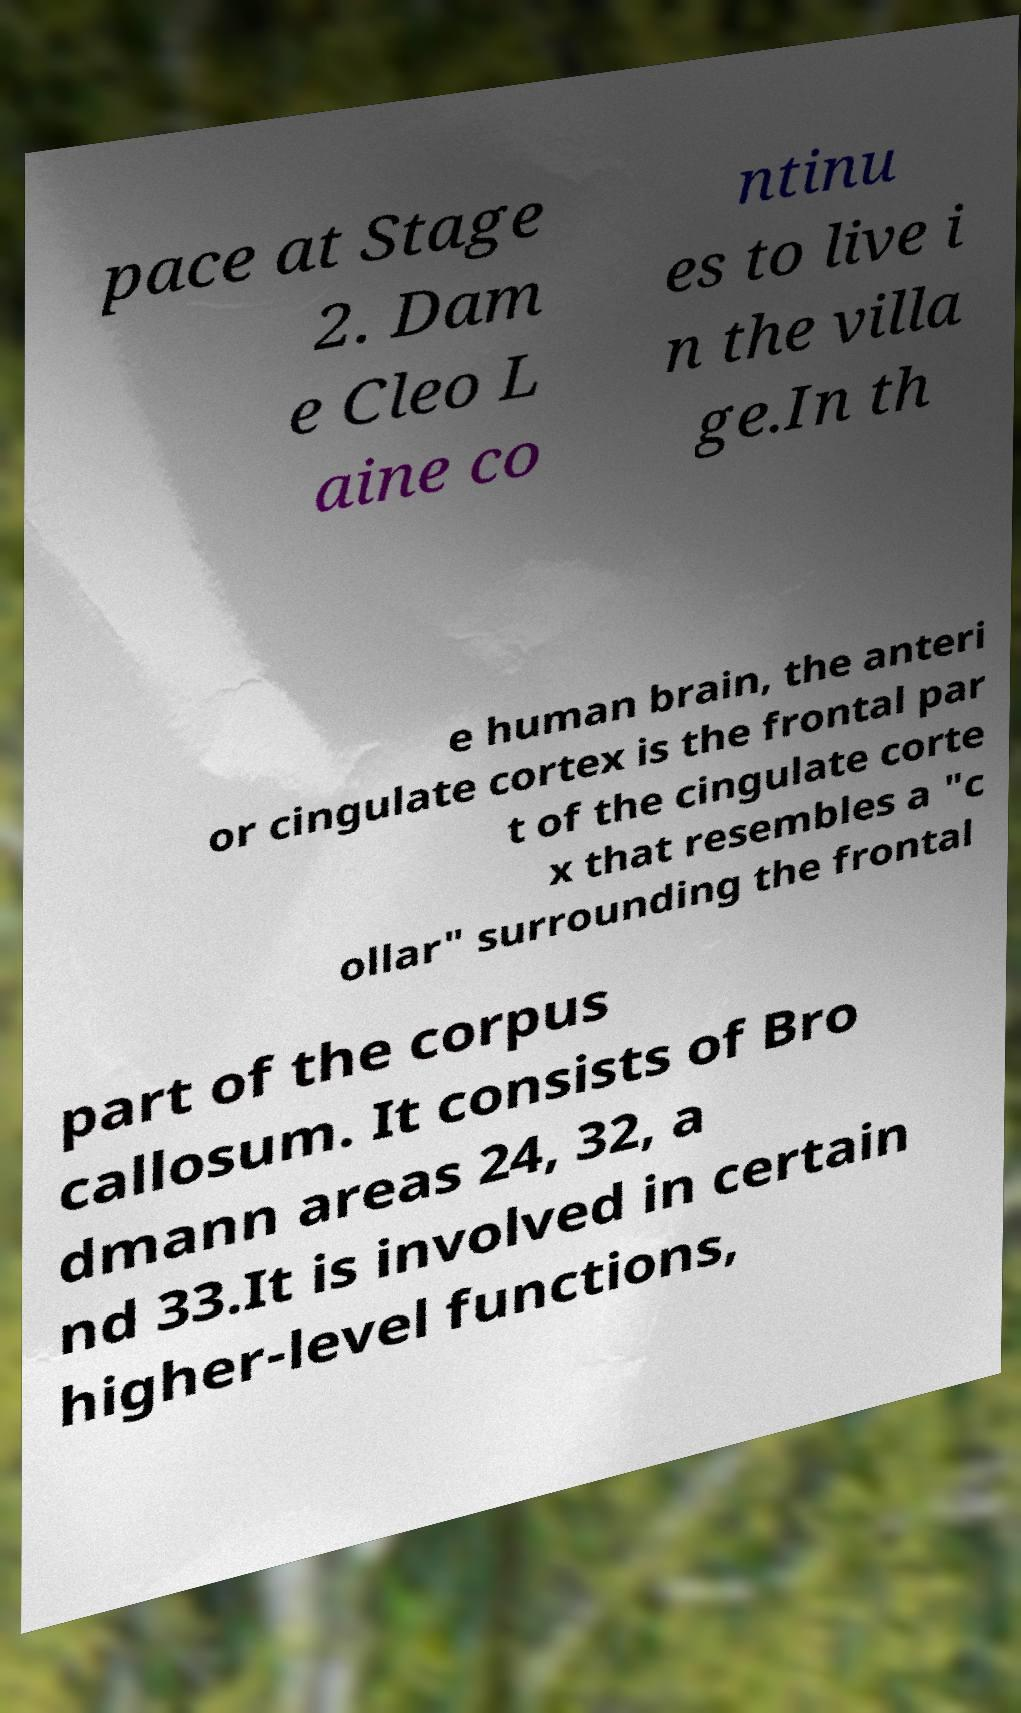What messages or text are displayed in this image? I need them in a readable, typed format. pace at Stage 2. Dam e Cleo L aine co ntinu es to live i n the villa ge.In th e human brain, the anteri or cingulate cortex is the frontal par t of the cingulate corte x that resembles a "c ollar" surrounding the frontal part of the corpus callosum. It consists of Bro dmann areas 24, 32, a nd 33.It is involved in certain higher-level functions, 